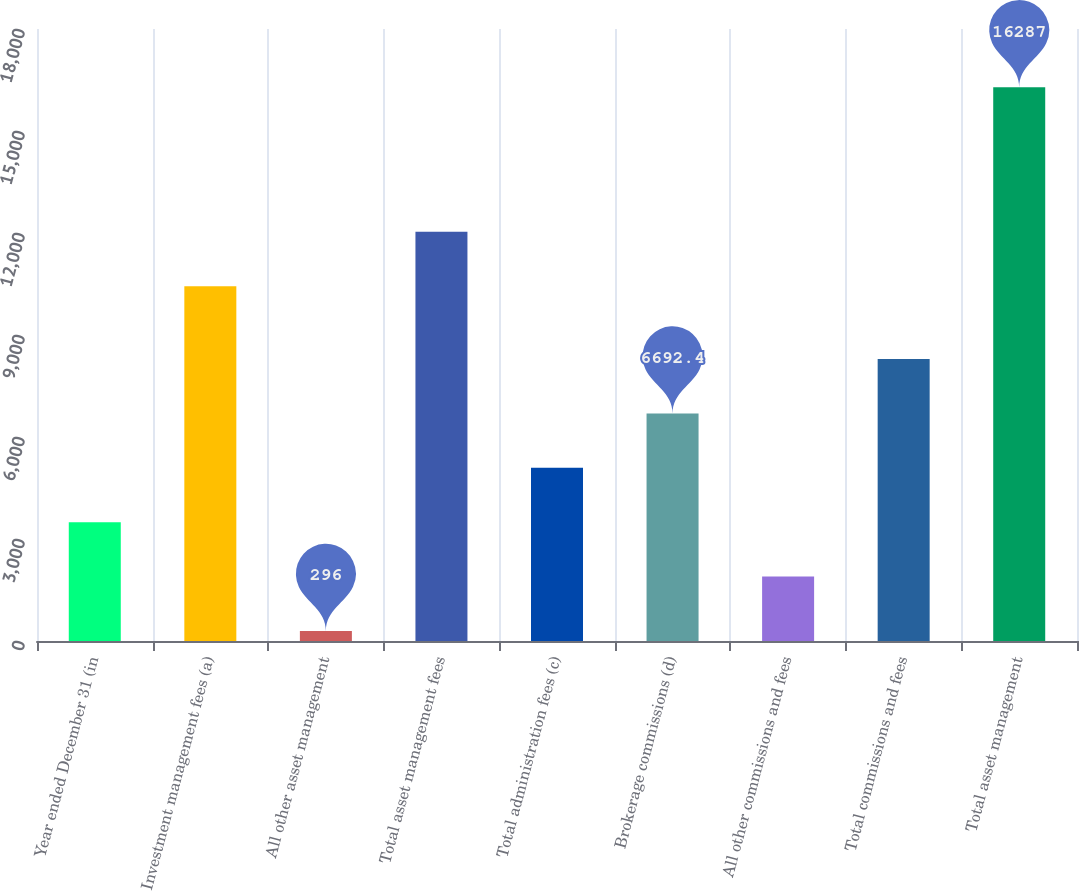<chart> <loc_0><loc_0><loc_500><loc_500><bar_chart><fcel>Year ended December 31 (in<fcel>Investment management fees (a)<fcel>All other asset management<fcel>Total asset management fees<fcel>Total administration fees (c)<fcel>Brokerage commissions (d)<fcel>All other commissions and fees<fcel>Total commissions and fees<fcel>Total asset management<nl><fcel>3494.2<fcel>10434<fcel>296<fcel>12033.1<fcel>5093.3<fcel>6692.4<fcel>1895.1<fcel>8291.5<fcel>16287<nl></chart> 